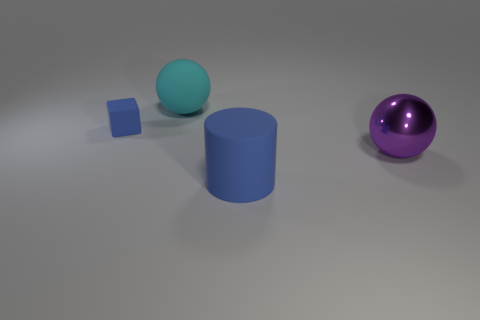Add 4 large cyan rubber balls. How many objects exist? 8 Subtract all cubes. How many objects are left? 3 Subtract all large matte objects. Subtract all cylinders. How many objects are left? 1 Add 3 blue things. How many blue things are left? 5 Add 3 matte cubes. How many matte cubes exist? 4 Subtract 0 red cubes. How many objects are left? 4 Subtract all green cubes. Subtract all blue cylinders. How many cubes are left? 1 